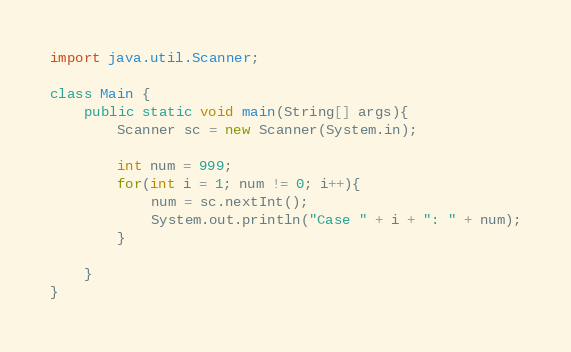<code> <loc_0><loc_0><loc_500><loc_500><_Java_>import java.util.Scanner;

class Main {
	public static void main(String[] args){
		Scanner sc = new Scanner(System.in);
		
		int num = 999;
		for(int i = 1; num != 0; i++){
			num = sc.nextInt();
			System.out.println("Case " + i + ": " + num);
		}
		
	}
}</code> 